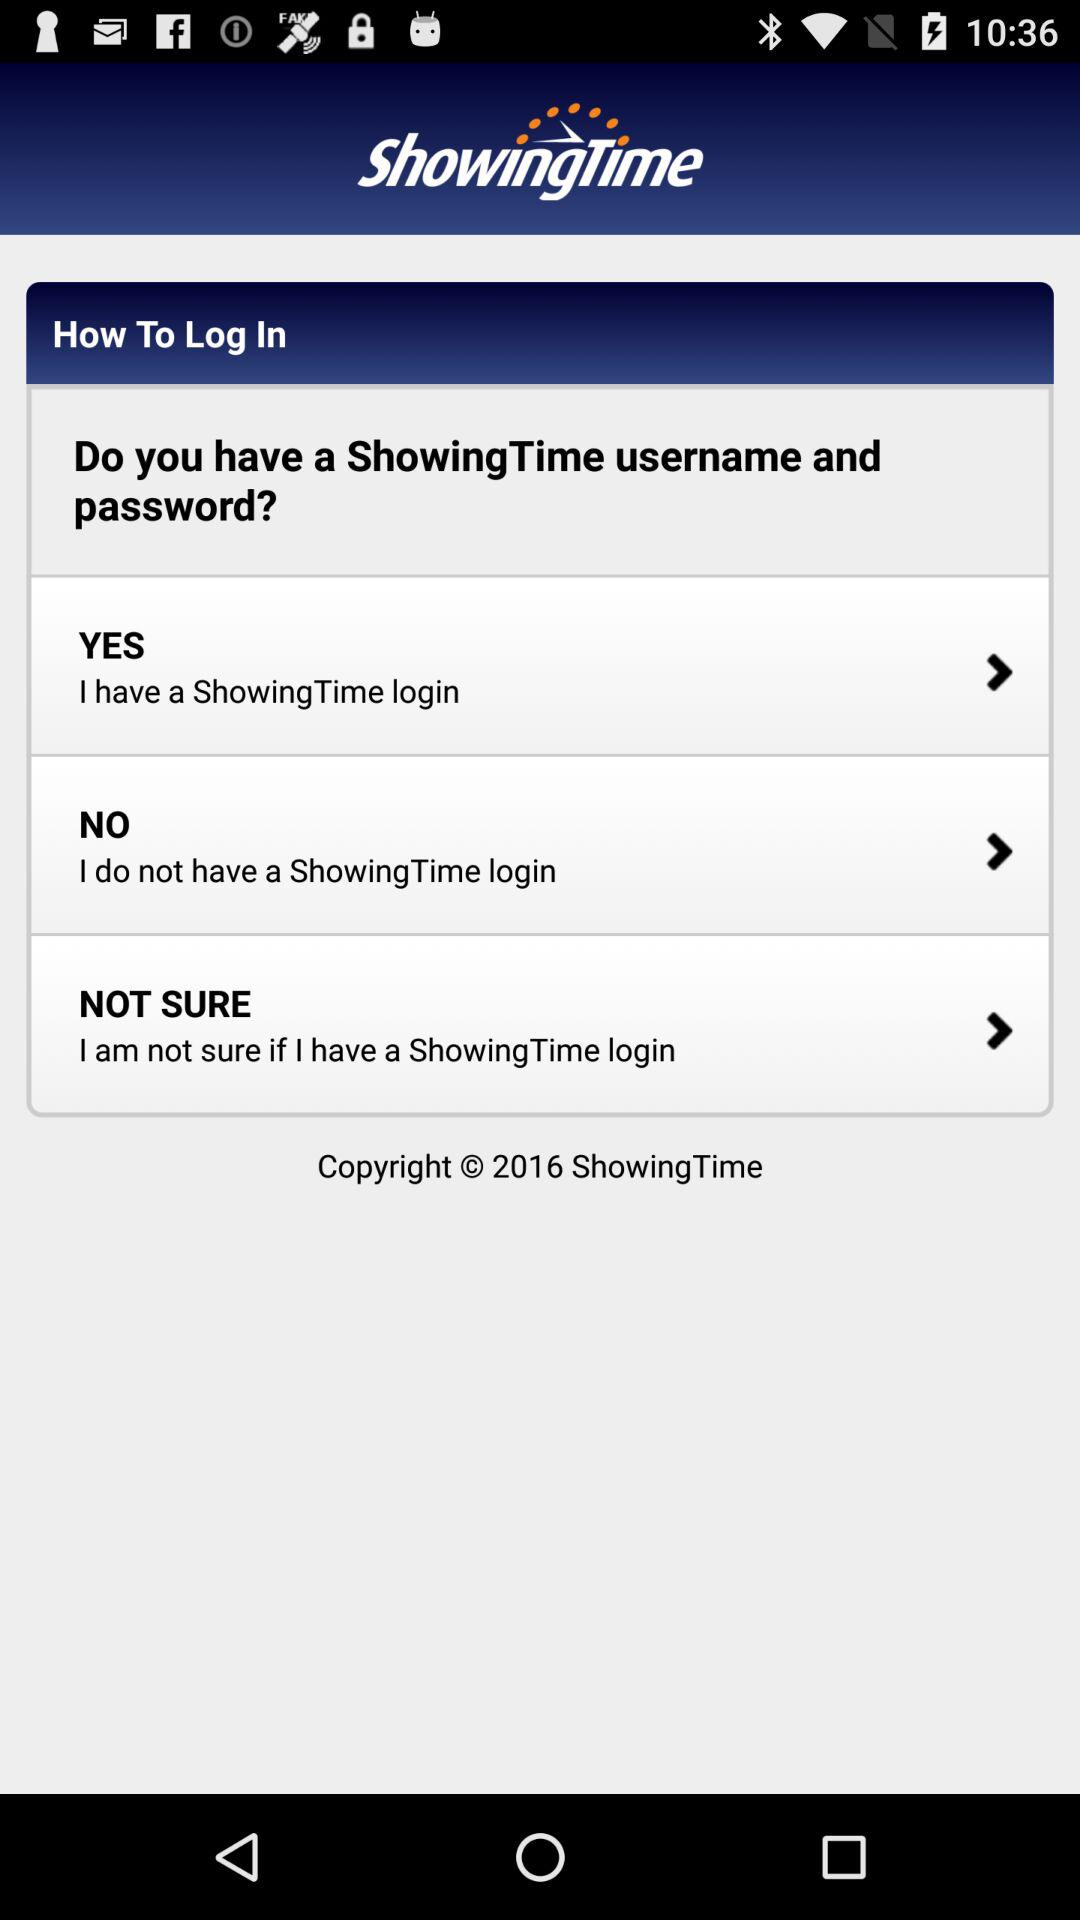What is the application name? The application name is "ShowingTime". 